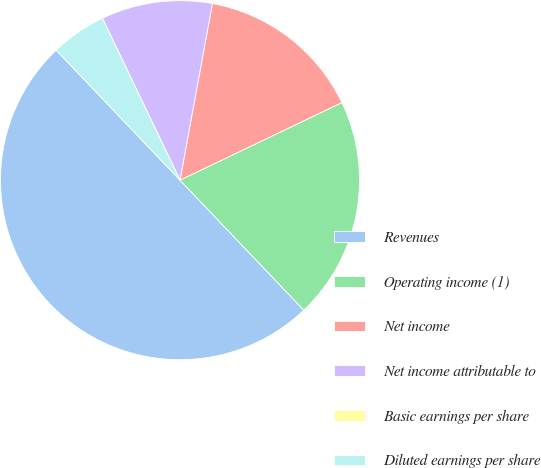Convert chart. <chart><loc_0><loc_0><loc_500><loc_500><pie_chart><fcel>Revenues<fcel>Operating income (1)<fcel>Net income<fcel>Net income attributable to<fcel>Basic earnings per share<fcel>Diluted earnings per share<nl><fcel>50.0%<fcel>20.0%<fcel>15.0%<fcel>10.0%<fcel>0.0%<fcel>5.0%<nl></chart> 